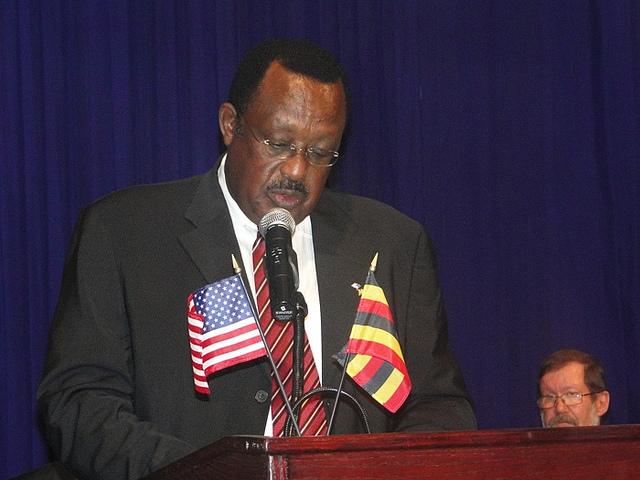What countries do the flags represent?
Concise answer only. Usa and uganda. Is the man speaking into a microphone?
Quick response, please. Yes. Is there anyone in this picture without glasses?
Give a very brief answer. No. What color is the man's jacket?
Write a very short answer. Black. 